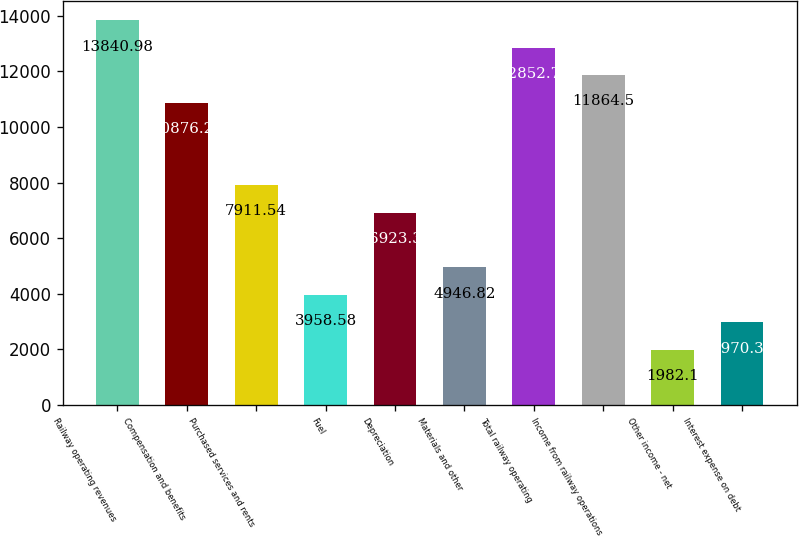Convert chart. <chart><loc_0><loc_0><loc_500><loc_500><bar_chart><fcel>Railway operating revenues<fcel>Compensation and benefits<fcel>Purchased services and rents<fcel>Fuel<fcel>Depreciation<fcel>Materials and other<fcel>Total railway operating<fcel>Income from railway operations<fcel>Other income - net<fcel>Interest expense on debt<nl><fcel>13841<fcel>10876.3<fcel>7911.54<fcel>3958.58<fcel>6923.3<fcel>4946.82<fcel>12852.7<fcel>11864.5<fcel>1982.1<fcel>2970.34<nl></chart> 